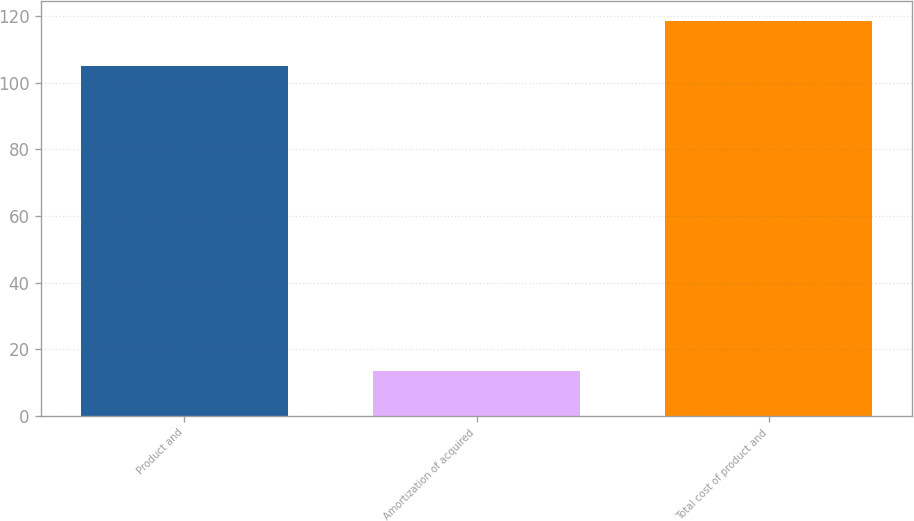<chart> <loc_0><loc_0><loc_500><loc_500><bar_chart><fcel>Product and<fcel>Amortization of acquired<fcel>Total cost of product and<nl><fcel>105<fcel>13.5<fcel>118.5<nl></chart> 